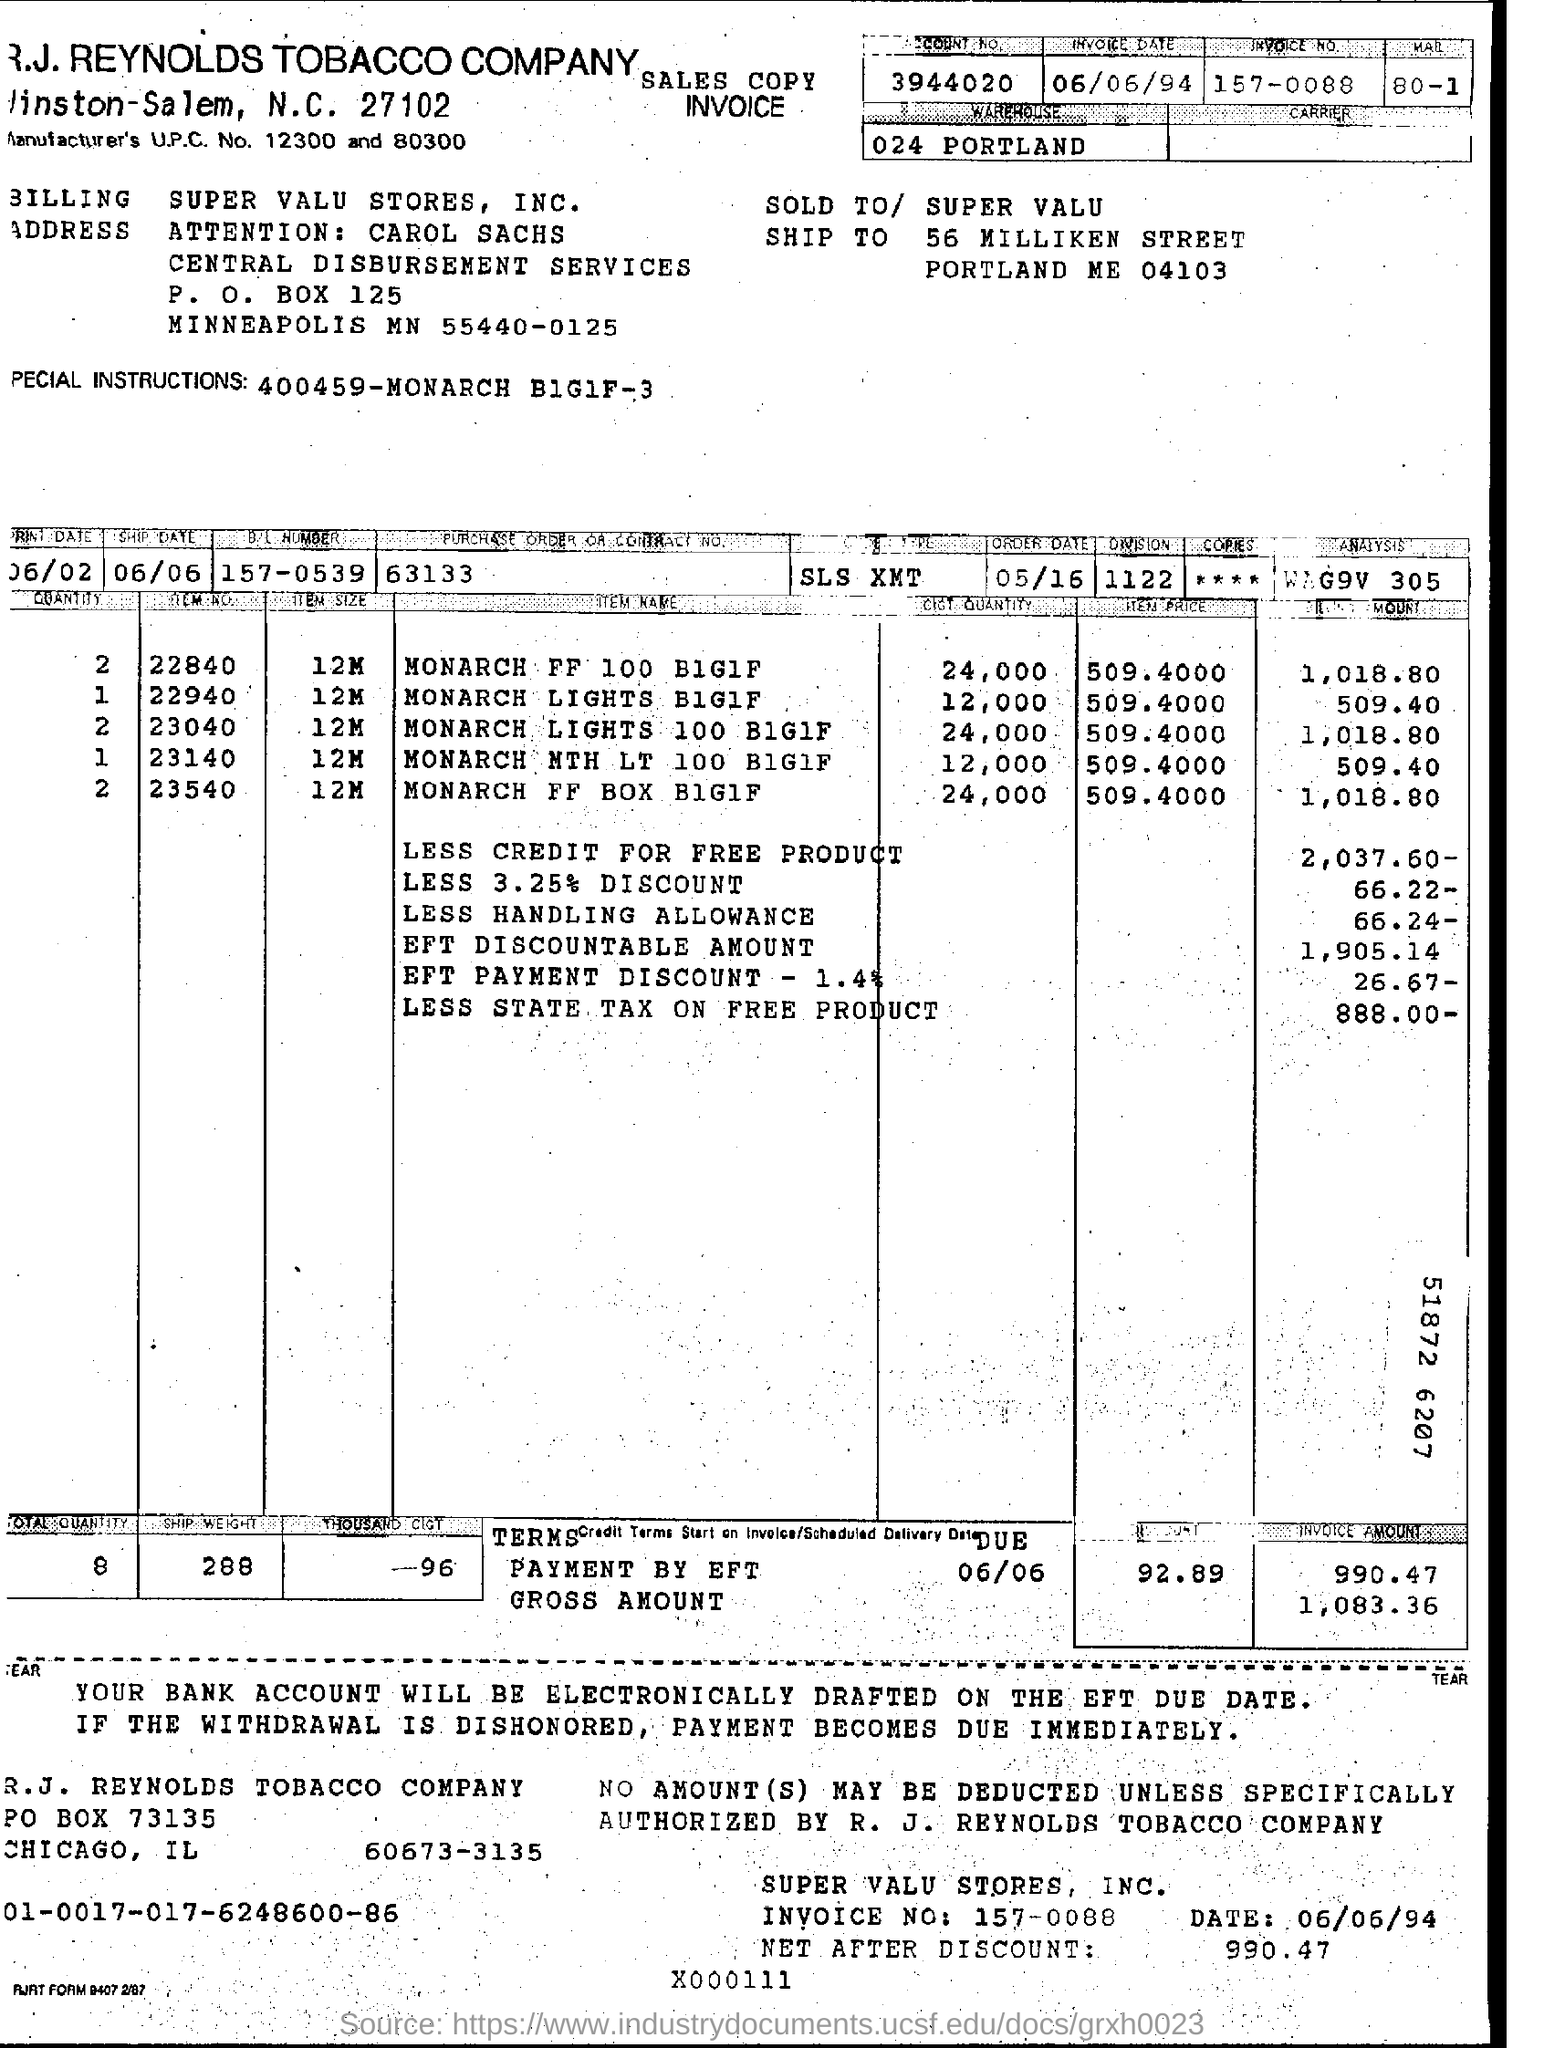What is the item price of MONARCH FF 100 BIGIF?
Provide a short and direct response. 509.4000. What is the Manufacturer's U.PC. No.?
Keep it short and to the point. Manufacturer's U.PC. No. 12300 and 80300. What is the invoice date?
Provide a succinct answer. 06/06/94. 